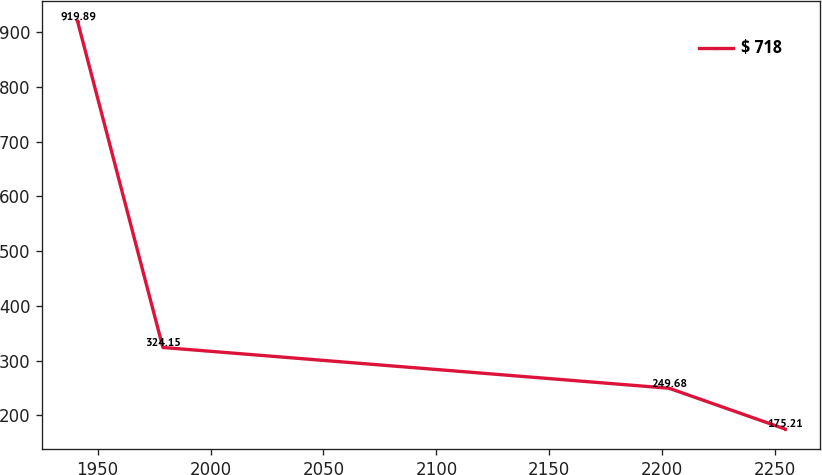Convert chart. <chart><loc_0><loc_0><loc_500><loc_500><line_chart><ecel><fcel>$ 718<nl><fcel>1941.13<fcel>919.89<nl><fcel>1978.9<fcel>324.15<nl><fcel>2203<fcel>249.68<nl><fcel>2254.35<fcel>175.21<nl></chart> 